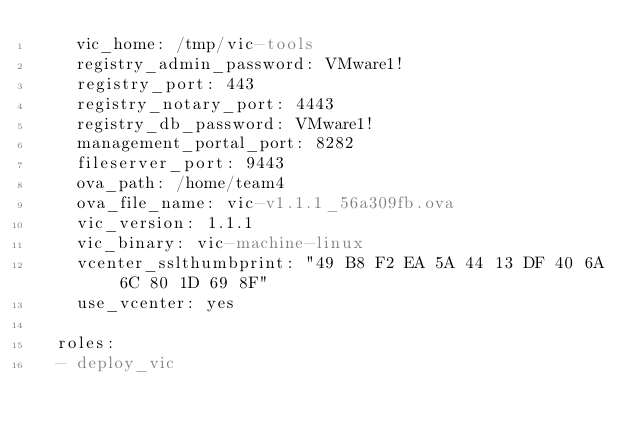<code> <loc_0><loc_0><loc_500><loc_500><_YAML_>    vic_home: /tmp/vic-tools
    registry_admin_password: VMware1!
    registry_port: 443
    registry_notary_port: 4443
    registry_db_password: VMware1!
    management_portal_port: 8282
    fileserver_port: 9443
    ova_path: /home/team4
    ova_file_name: vic-v1.1.1_56a309fb.ova
    vic_version: 1.1.1
    vic_binary: vic-machine-linux
    vcenter_sslthumbprint: "49 B8 F2 EA 5A 44 13 DF 40 6A 6C 80 1D 69 8F"
    use_vcenter: yes
    
  roles:
  - deploy_vic

</code> 